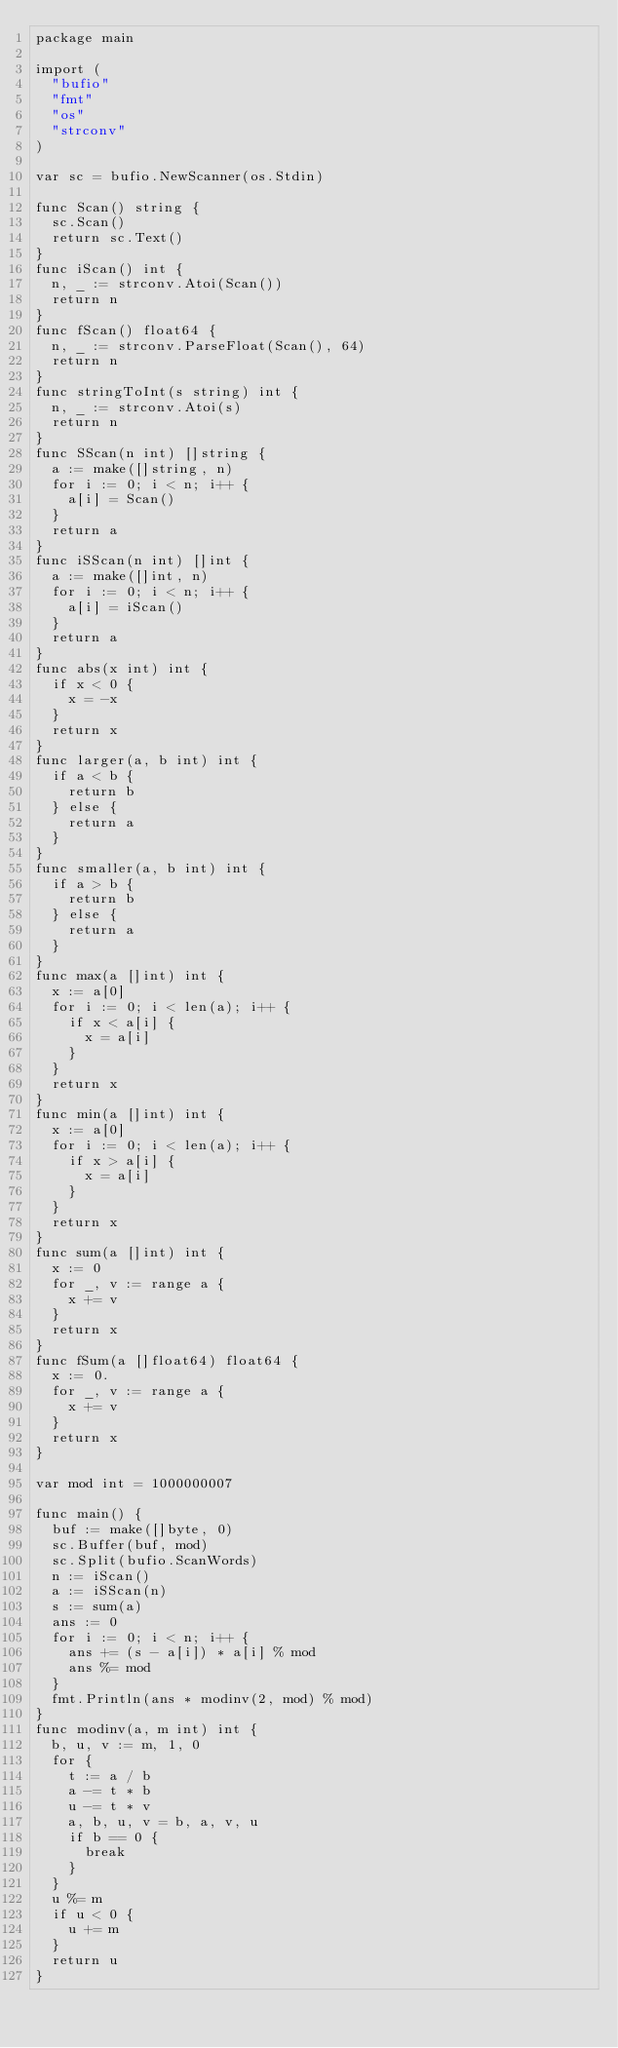Convert code to text. <code><loc_0><loc_0><loc_500><loc_500><_Go_>package main

import (
	"bufio"
	"fmt"
	"os"
	"strconv"
)

var sc = bufio.NewScanner(os.Stdin)

func Scan() string {
	sc.Scan()
	return sc.Text()
}
func iScan() int {
	n, _ := strconv.Atoi(Scan())
	return n
}
func fScan() float64 {
	n, _ := strconv.ParseFloat(Scan(), 64)
	return n
}
func stringToInt(s string) int {
	n, _ := strconv.Atoi(s)
	return n
}
func SScan(n int) []string {
	a := make([]string, n)
	for i := 0; i < n; i++ {
		a[i] = Scan()
	}
	return a
}
func iSScan(n int) []int {
	a := make([]int, n)
	for i := 0; i < n; i++ {
		a[i] = iScan()
	}
	return a
}
func abs(x int) int {
	if x < 0 {
		x = -x
	}
	return x
}
func larger(a, b int) int {
	if a < b {
		return b
	} else {
		return a
	}
}
func smaller(a, b int) int {
	if a > b {
		return b
	} else {
		return a
	}
}
func max(a []int) int {
	x := a[0]
	for i := 0; i < len(a); i++ {
		if x < a[i] {
			x = a[i]
		}
	}
	return x
}
func min(a []int) int {
	x := a[0]
	for i := 0; i < len(a); i++ {
		if x > a[i] {
			x = a[i]
		}
	}
	return x
}
func sum(a []int) int {
	x := 0
	for _, v := range a {
		x += v
	}
	return x
}
func fSum(a []float64) float64 {
	x := 0.
	for _, v := range a {
		x += v
	}
	return x
}

var mod int = 1000000007

func main() {
	buf := make([]byte, 0)
	sc.Buffer(buf, mod)
	sc.Split(bufio.ScanWords)
	n := iScan()
	a := iSScan(n)
	s := sum(a)
	ans := 0
	for i := 0; i < n; i++ {
		ans += (s - a[i]) * a[i] % mod
		ans %= mod
	}
	fmt.Println(ans * modinv(2, mod) % mod)
}
func modinv(a, m int) int {
	b, u, v := m, 1, 0
	for {
		t := a / b
		a -= t * b
		u -= t * v
		a, b, u, v = b, a, v, u
		if b == 0 {
			break
		}
	}
	u %= m
	if u < 0 {
		u += m
	}
	return u
}
</code> 